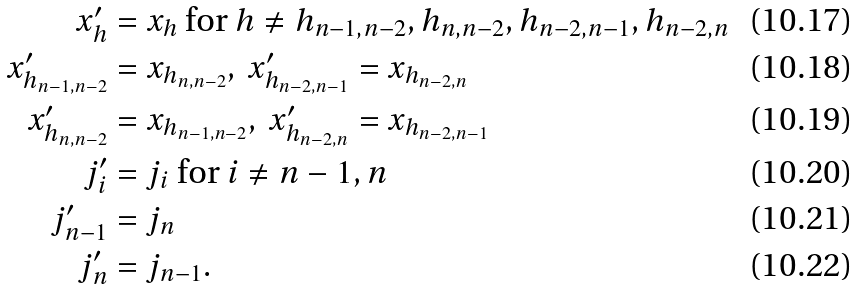Convert formula to latex. <formula><loc_0><loc_0><loc_500><loc_500>x ^ { \prime } _ { h } & = x _ { h } \text { for } h \ne h _ { n - 1 , n - 2 } , h _ { n , n - 2 } , h _ { n - 2 , n - 1 } , h _ { n - 2 , n } \\ x ^ { \prime } _ { h _ { n - 1 , n - 2 } } & = x _ { h _ { n , n - 2 } } , \ x ^ { \prime } _ { h _ { n - 2 , n - 1 } } = x _ { h _ { n - 2 , n } } \\ x ^ { \prime } _ { h _ { n , n - 2 } } & = x _ { h _ { n - 1 , n - 2 } } , \ x ^ { \prime } _ { h _ { n - 2 , n } } = x _ { h _ { n - 2 , n - 1 } } \\ j ^ { \prime } _ { i } & = j _ { i } \text { for } i \ne n - 1 , n \\ j ^ { \prime } _ { n - 1 } & = j _ { n } \\ j ^ { \prime } _ { n } & = j _ { n - 1 } .</formula> 